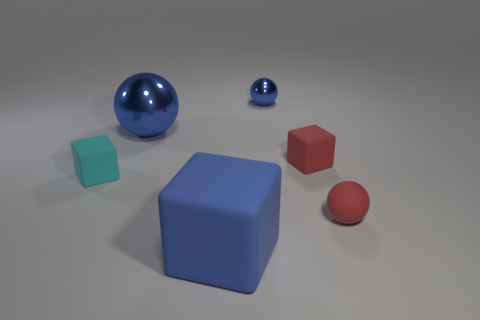Subtract all purple blocks. How many blue spheres are left? 2 Subtract all tiny balls. How many balls are left? 1 Add 2 big rubber objects. How many objects exist? 8 Subtract all brown spheres. Subtract all blue cylinders. How many spheres are left? 3 Add 4 small red matte objects. How many small red matte objects are left? 6 Add 3 blue rubber cubes. How many blue rubber cubes exist? 4 Subtract 1 red spheres. How many objects are left? 5 Subtract all red rubber things. Subtract all matte things. How many objects are left? 0 